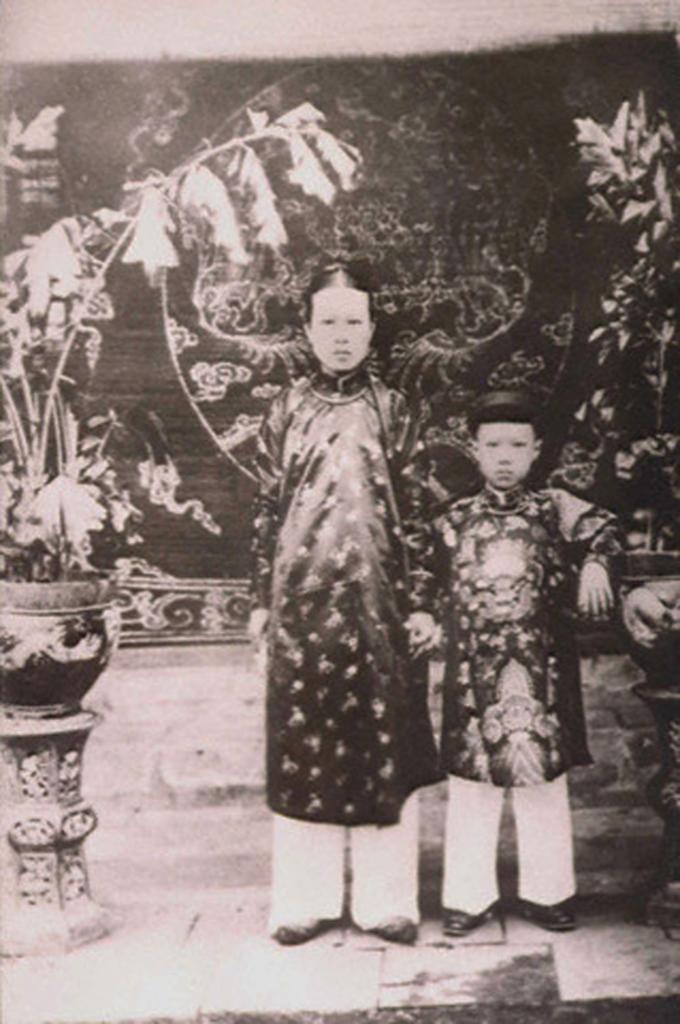How would you summarize this image in a sentence or two? This is a black and white picture, in this image we can see two persons standing on the ground, there are some potted plants on the stands, in the background we can see the wall. 